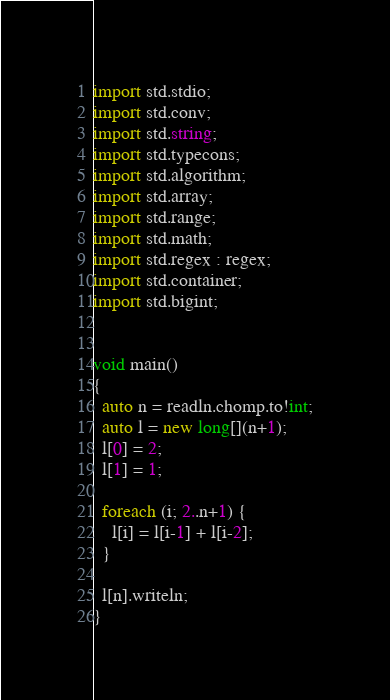Convert code to text. <code><loc_0><loc_0><loc_500><loc_500><_D_>import std.stdio;
import std.conv;
import std.string;
import std.typecons;
import std.algorithm;
import std.array;
import std.range;
import std.math;
import std.regex : regex;
import std.container;
import std.bigint;


void main()
{
  auto n = readln.chomp.to!int;
  auto l = new long[](n+1);
  l[0] = 2;
  l[1] = 1;

  foreach (i; 2..n+1) {
    l[i] = l[i-1] + l[i-2];
  }

  l[n].writeln;
}
</code> 